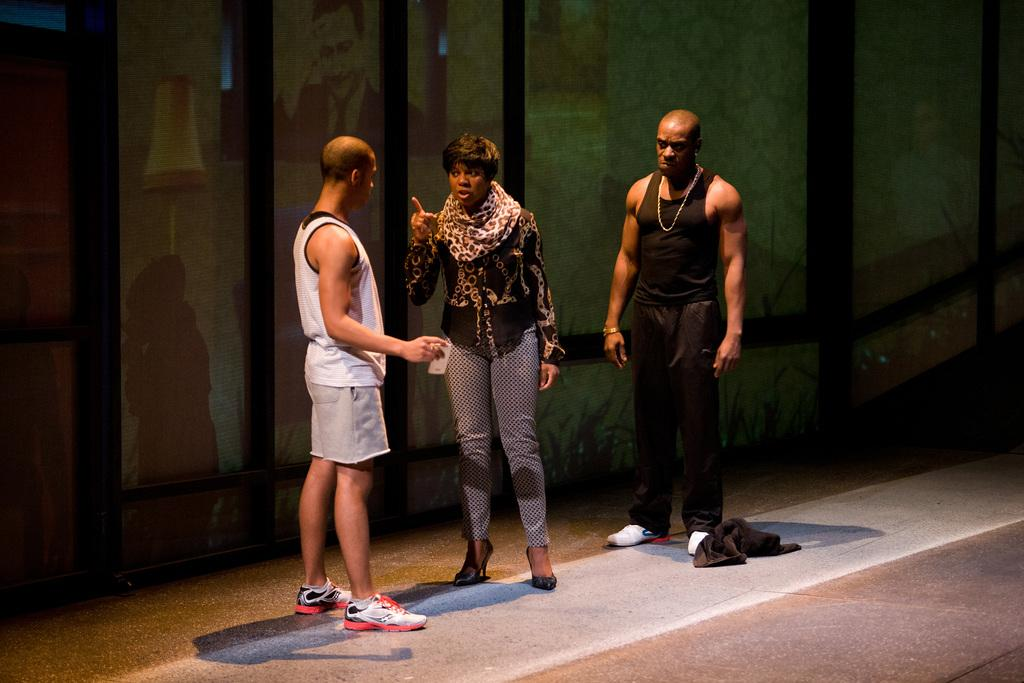How many people are present in the image? There are three persons standing in the image. What is the surface on which the persons are standing? The persons are standing on the floor. What can be seen on the glasses that the persons are wearing? There are pictures of persons on the glasses. What is the additional item visible on the floor in the image? There is a cloth on the floor in the image. What type of thunder can be heard in the image? There is no thunder present in the image, as it is a still photograph. Is there any indication of an attack happening in the image? There is no indication of an attack in the image; it shows three people standing with pictures on their glasses and a cloth on the floor. 